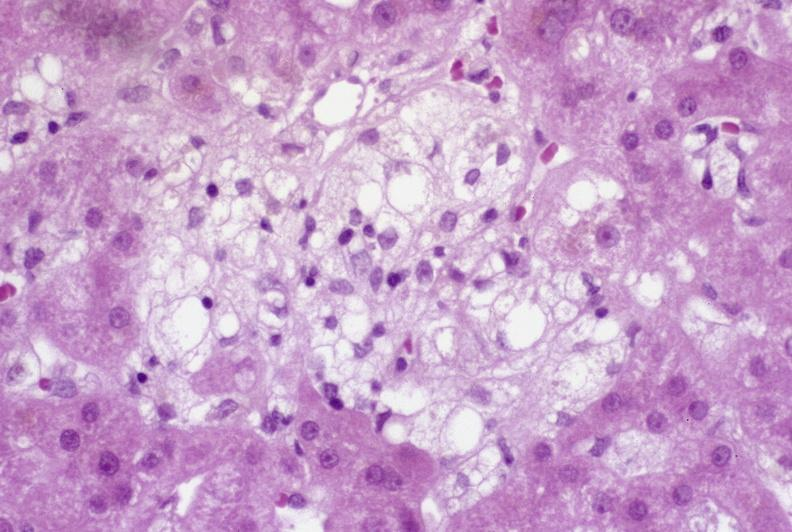does anencephaly and bilateral cleft palate show recovery of ducts?
Answer the question using a single word or phrase. No 